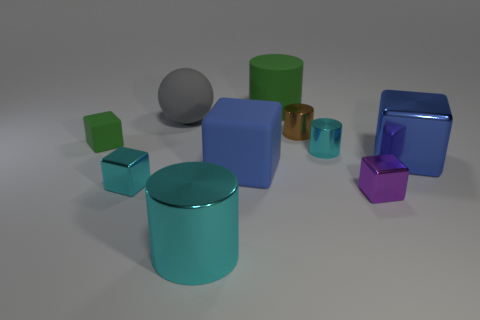There is a rubber cylinder; is its color the same as the matte cube that is on the left side of the large cyan metallic cylinder?
Offer a terse response. Yes. Is the material of the brown cylinder the same as the blue block that is on the left side of the big blue metallic block?
Your response must be concise. No. How many things are blue cubes or rubber balls?
Give a very brief answer. 3. What material is the object that is the same color as the large rubber cube?
Your answer should be very brief. Metal. Are there any tiny rubber objects that have the same shape as the big green matte object?
Your answer should be compact. No. How many green blocks are to the right of the blue rubber cube?
Ensure brevity in your answer.  0. There is a tiny cyan object left of the cylinder in front of the purple metallic object; what is it made of?
Your answer should be compact. Metal. What material is the green thing that is the same size as the gray rubber thing?
Offer a terse response. Rubber. Are there any yellow rubber cylinders that have the same size as the sphere?
Offer a very short reply. No. There is a big cylinder that is in front of the large rubber block; what color is it?
Provide a succinct answer. Cyan. 